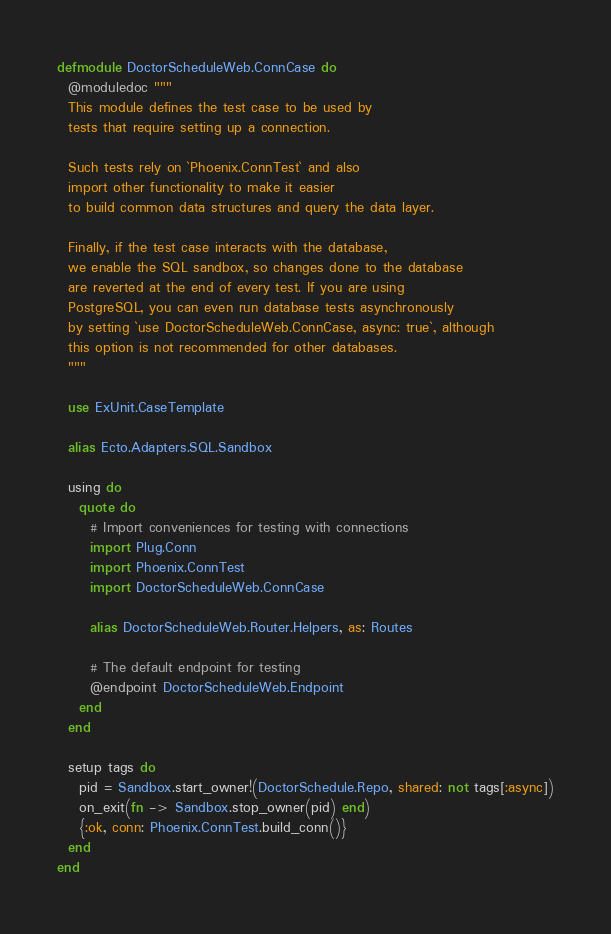<code> <loc_0><loc_0><loc_500><loc_500><_Elixir_>defmodule DoctorScheduleWeb.ConnCase do
  @moduledoc """
  This module defines the test case to be used by
  tests that require setting up a connection.

  Such tests rely on `Phoenix.ConnTest` and also
  import other functionality to make it easier
  to build common data structures and query the data layer.

  Finally, if the test case interacts with the database,
  we enable the SQL sandbox, so changes done to the database
  are reverted at the end of every test. If you are using
  PostgreSQL, you can even run database tests asynchronously
  by setting `use DoctorScheduleWeb.ConnCase, async: true`, although
  this option is not recommended for other databases.
  """

  use ExUnit.CaseTemplate

  alias Ecto.Adapters.SQL.Sandbox

  using do
    quote do
      # Import conveniences for testing with connections
      import Plug.Conn
      import Phoenix.ConnTest
      import DoctorScheduleWeb.ConnCase

      alias DoctorScheduleWeb.Router.Helpers, as: Routes

      # The default endpoint for testing
      @endpoint DoctorScheduleWeb.Endpoint
    end
  end

  setup tags do
    pid = Sandbox.start_owner!(DoctorSchedule.Repo, shared: not tags[:async])
    on_exit(fn -> Sandbox.stop_owner(pid) end)
    {:ok, conn: Phoenix.ConnTest.build_conn()}
  end
end
</code> 